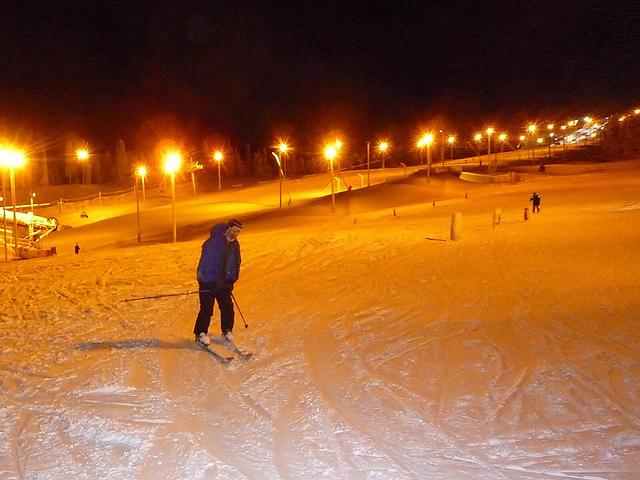Is the man skiing at night?
Keep it brief. Yes. What color is the sky?
Quick response, please. Black. How many people are in this picture?
Be succinct. 2. 